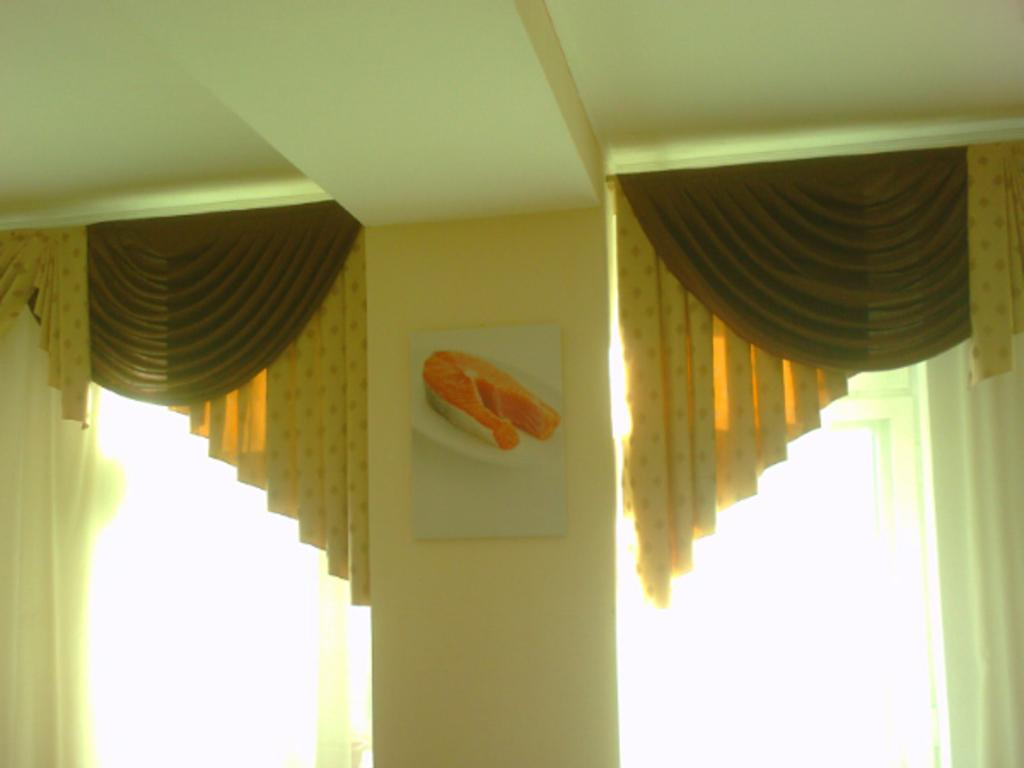What is the main architectural feature in the image? There is a beam in the image. What type of covering is present in the image? There is a curtain in the image. What allows natural light to enter the space? There is a window in the image. What is the primary structural element in the image? There is a wall in the image. What is hanging on the wall in the image? There is a photo frame on the wall. What is inside the photo frame? The photo frame contains an image. How is the curtain positioned in the image? A curtain is hanging through the window. What type of space exploration is depicted in the image? There is no depiction of space exploration in the image; it features a beam, curtain, window, wall, photo frame, and curtain hanging through the window. 